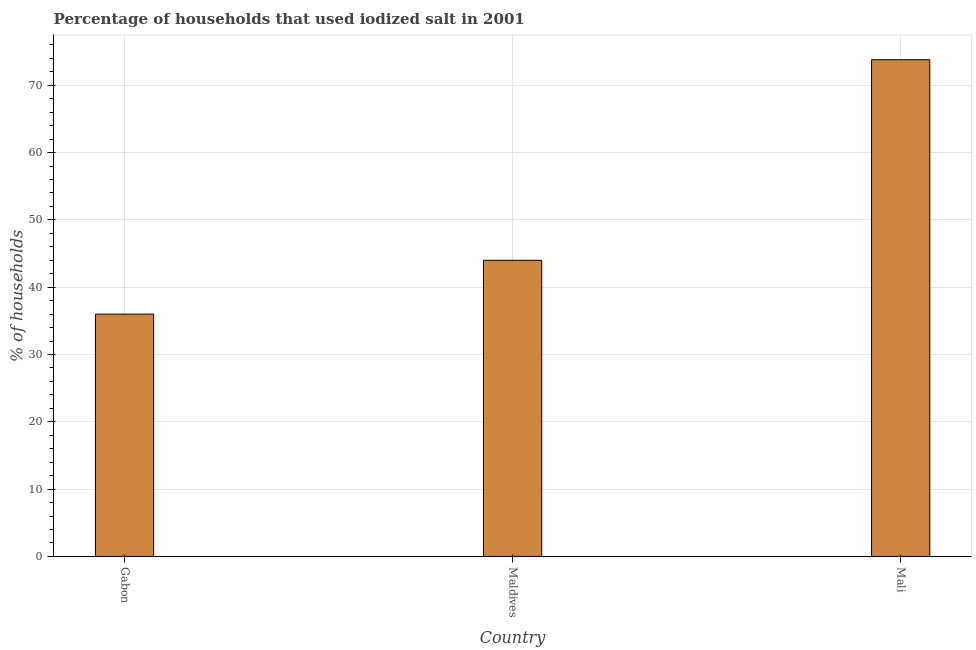What is the title of the graph?
Give a very brief answer. Percentage of households that used iodized salt in 2001. What is the label or title of the Y-axis?
Make the answer very short. % of households. What is the percentage of households where iodized salt is consumed in Gabon?
Keep it short and to the point. 36. Across all countries, what is the maximum percentage of households where iodized salt is consumed?
Your answer should be compact. 73.8. In which country was the percentage of households where iodized salt is consumed maximum?
Your answer should be very brief. Mali. In which country was the percentage of households where iodized salt is consumed minimum?
Provide a short and direct response. Gabon. What is the sum of the percentage of households where iodized salt is consumed?
Ensure brevity in your answer.  153.8. What is the difference between the percentage of households where iodized salt is consumed in Maldives and Mali?
Keep it short and to the point. -29.8. What is the average percentage of households where iodized salt is consumed per country?
Make the answer very short. 51.27. What is the median percentage of households where iodized salt is consumed?
Give a very brief answer. 44. In how many countries, is the percentage of households where iodized salt is consumed greater than 14 %?
Your answer should be compact. 3. What is the ratio of the percentage of households where iodized salt is consumed in Maldives to that in Mali?
Make the answer very short. 0.6. Is the difference between the percentage of households where iodized salt is consumed in Maldives and Mali greater than the difference between any two countries?
Ensure brevity in your answer.  No. What is the difference between the highest and the second highest percentage of households where iodized salt is consumed?
Offer a very short reply. 29.8. Is the sum of the percentage of households where iodized salt is consumed in Gabon and Maldives greater than the maximum percentage of households where iodized salt is consumed across all countries?
Your answer should be very brief. Yes. What is the difference between the highest and the lowest percentage of households where iodized salt is consumed?
Ensure brevity in your answer.  37.8. How many countries are there in the graph?
Provide a succinct answer. 3. What is the difference between two consecutive major ticks on the Y-axis?
Your answer should be compact. 10. Are the values on the major ticks of Y-axis written in scientific E-notation?
Your response must be concise. No. What is the % of households in Mali?
Provide a short and direct response. 73.8. What is the difference between the % of households in Gabon and Maldives?
Provide a succinct answer. -8. What is the difference between the % of households in Gabon and Mali?
Provide a succinct answer. -37.8. What is the difference between the % of households in Maldives and Mali?
Your answer should be very brief. -29.8. What is the ratio of the % of households in Gabon to that in Maldives?
Keep it short and to the point. 0.82. What is the ratio of the % of households in Gabon to that in Mali?
Give a very brief answer. 0.49. What is the ratio of the % of households in Maldives to that in Mali?
Your response must be concise. 0.6. 